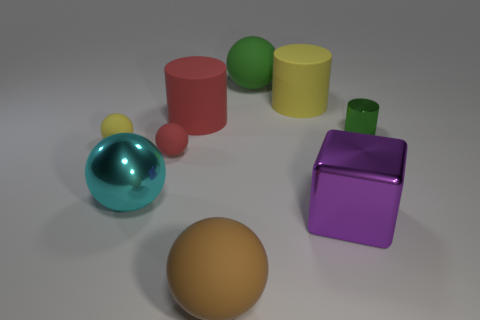Add 1 big yellow things. How many objects exist? 10 Subtract all red matte balls. How many balls are left? 4 Subtract all red balls. How many balls are left? 4 Subtract 3 balls. How many balls are left? 2 Subtract all spheres. How many objects are left? 4 Subtract all blue balls. Subtract all green cubes. How many balls are left? 5 Subtract all brown balls. Subtract all large metal cubes. How many objects are left? 7 Add 4 large purple shiny cubes. How many large purple shiny cubes are left? 5 Add 9 small cylinders. How many small cylinders exist? 10 Subtract 1 green cylinders. How many objects are left? 8 